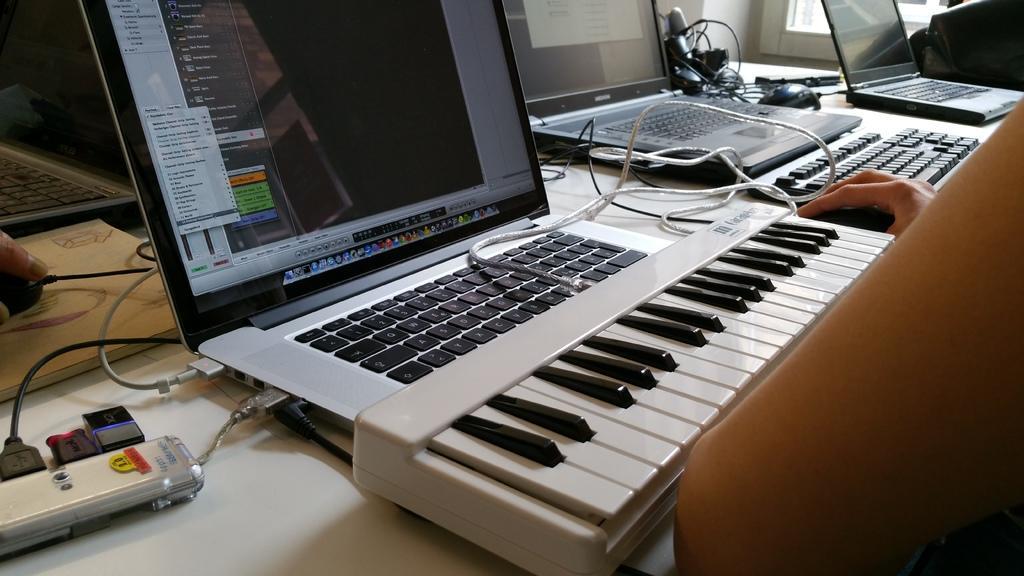In one or two sentences, can you explain what this image depicts? It is a laptop in black color. 